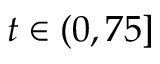<formula> <loc_0><loc_0><loc_500><loc_500>t \in ( 0 , 7 5 ]</formula> 